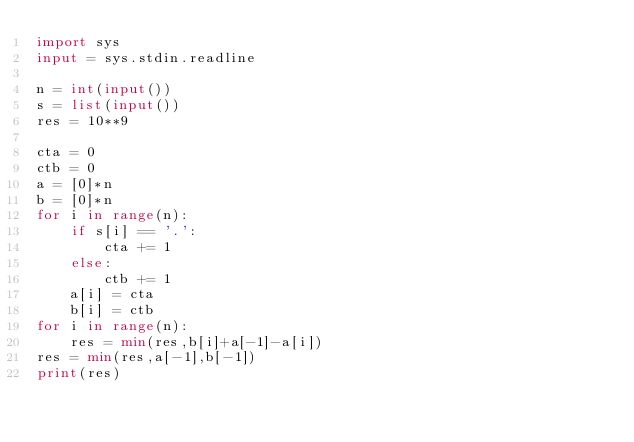Convert code to text. <code><loc_0><loc_0><loc_500><loc_500><_Python_>import sys
input = sys.stdin.readline

n = int(input())
s = list(input())
res = 10**9

cta = 0
ctb = 0
a = [0]*n
b = [0]*n
for i in range(n):
    if s[i] == '.':
        cta += 1
    else:
        ctb += 1
    a[i] = cta
    b[i] = ctb
for i in range(n):
    res = min(res,b[i]+a[-1]-a[i])
res = min(res,a[-1],b[-1])
print(res)</code> 